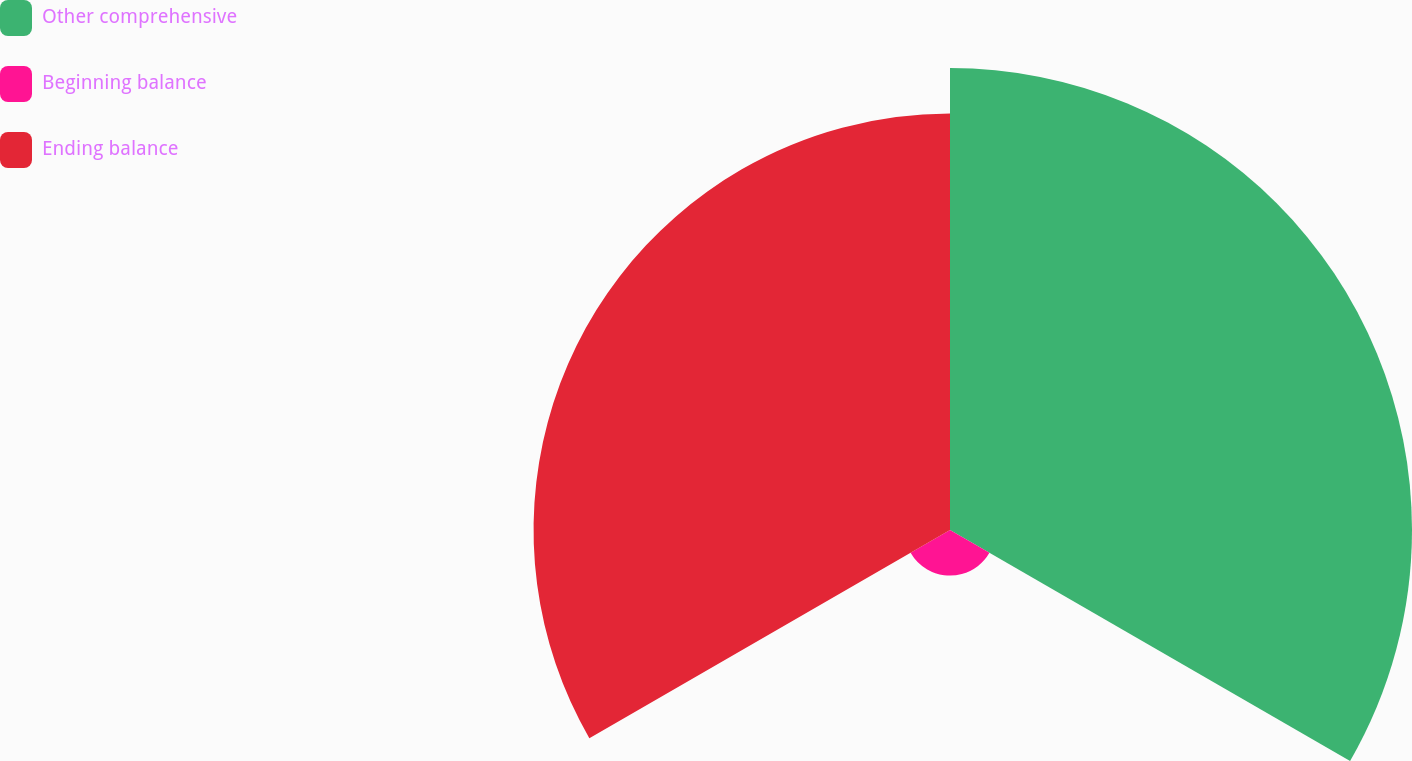<chart> <loc_0><loc_0><loc_500><loc_500><pie_chart><fcel>Other comprehensive<fcel>Beginning balance<fcel>Ending balance<nl><fcel>50.0%<fcel>4.93%<fcel>45.07%<nl></chart> 